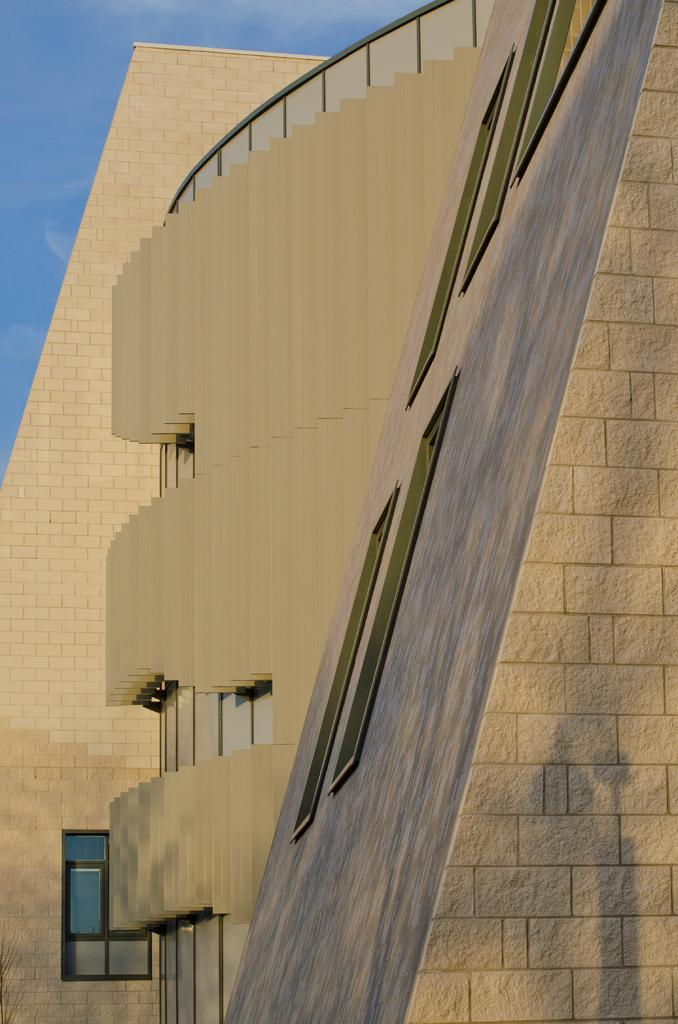What structures can be seen in the image? There are a few buildings in the image. What part of the natural environment is visible in the image? The sky is visible in the image. Where are the kittens located in the image? There are no kittens present in the image. What type of insect can be seen flying in the sky in the image? There is no insect visible in the image; only the sky and buildings are present. 